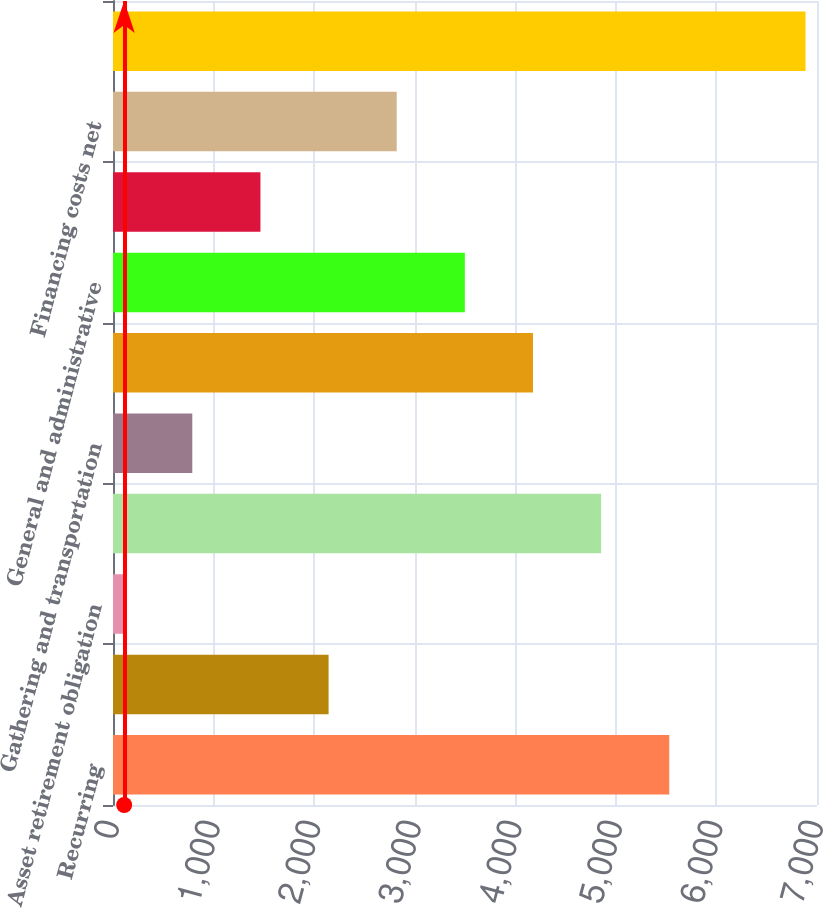Convert chart to OTSL. <chart><loc_0><loc_0><loc_500><loc_500><bar_chart><fcel>Recurring<fcel>Other assets<fcel>Asset retirement obligation<fcel>Lease operating costs<fcel>Gathering and transportation<fcel>Taxes other than income<fcel>General and administrative<fcel>Merger acquisitions &<fcel>Financing costs net<fcel>Total<nl><fcel>5531<fcel>2143.5<fcel>111<fcel>4853.5<fcel>788.5<fcel>4176<fcel>3498.5<fcel>1466<fcel>2821<fcel>6886<nl></chart> 